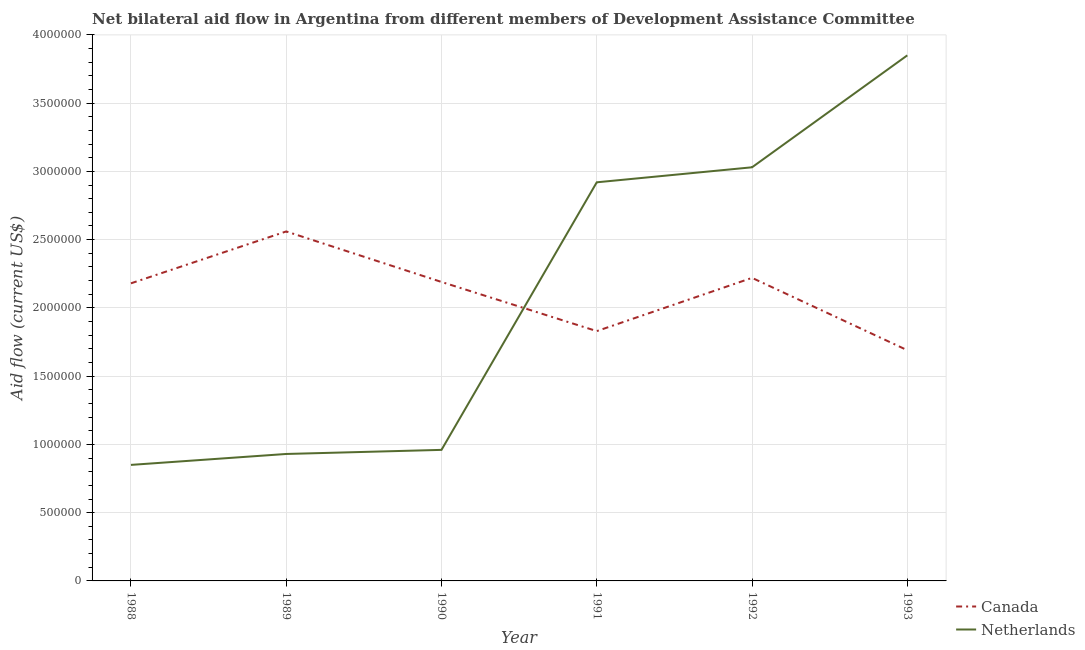Does the line corresponding to amount of aid given by canada intersect with the line corresponding to amount of aid given by netherlands?
Ensure brevity in your answer.  Yes. Is the number of lines equal to the number of legend labels?
Provide a short and direct response. Yes. What is the amount of aid given by netherlands in 1989?
Provide a short and direct response. 9.30e+05. Across all years, what is the maximum amount of aid given by canada?
Your answer should be compact. 2.56e+06. Across all years, what is the minimum amount of aid given by canada?
Your answer should be very brief. 1.69e+06. In which year was the amount of aid given by canada maximum?
Your answer should be very brief. 1989. In which year was the amount of aid given by netherlands minimum?
Provide a short and direct response. 1988. What is the total amount of aid given by canada in the graph?
Give a very brief answer. 1.27e+07. What is the difference between the amount of aid given by netherlands in 1988 and that in 1992?
Offer a terse response. -2.18e+06. What is the difference between the amount of aid given by canada in 1991 and the amount of aid given by netherlands in 1993?
Your answer should be very brief. -2.02e+06. What is the average amount of aid given by canada per year?
Your answer should be very brief. 2.11e+06. In the year 1991, what is the difference between the amount of aid given by canada and amount of aid given by netherlands?
Provide a short and direct response. -1.09e+06. In how many years, is the amount of aid given by netherlands greater than 2700000 US$?
Your answer should be very brief. 3. What is the ratio of the amount of aid given by netherlands in 1991 to that in 1993?
Your answer should be compact. 0.76. Is the difference between the amount of aid given by netherlands in 1989 and 1991 greater than the difference between the amount of aid given by canada in 1989 and 1991?
Your response must be concise. No. What is the difference between the highest and the lowest amount of aid given by netherlands?
Offer a terse response. 3.00e+06. Is the sum of the amount of aid given by netherlands in 1989 and 1992 greater than the maximum amount of aid given by canada across all years?
Your answer should be compact. Yes. How many years are there in the graph?
Your answer should be very brief. 6. What is the difference between two consecutive major ticks on the Y-axis?
Offer a very short reply. 5.00e+05. Are the values on the major ticks of Y-axis written in scientific E-notation?
Provide a succinct answer. No. Where does the legend appear in the graph?
Offer a terse response. Bottom right. How are the legend labels stacked?
Your answer should be compact. Vertical. What is the title of the graph?
Your response must be concise. Net bilateral aid flow in Argentina from different members of Development Assistance Committee. Does "Fraud firms" appear as one of the legend labels in the graph?
Keep it short and to the point. No. What is the label or title of the X-axis?
Provide a short and direct response. Year. What is the Aid flow (current US$) in Canada in 1988?
Keep it short and to the point. 2.18e+06. What is the Aid flow (current US$) in Netherlands in 1988?
Offer a terse response. 8.50e+05. What is the Aid flow (current US$) in Canada in 1989?
Keep it short and to the point. 2.56e+06. What is the Aid flow (current US$) in Netherlands in 1989?
Provide a succinct answer. 9.30e+05. What is the Aid flow (current US$) in Canada in 1990?
Ensure brevity in your answer.  2.19e+06. What is the Aid flow (current US$) in Netherlands in 1990?
Your answer should be compact. 9.60e+05. What is the Aid flow (current US$) of Canada in 1991?
Provide a succinct answer. 1.83e+06. What is the Aid flow (current US$) of Netherlands in 1991?
Give a very brief answer. 2.92e+06. What is the Aid flow (current US$) in Canada in 1992?
Your response must be concise. 2.22e+06. What is the Aid flow (current US$) of Netherlands in 1992?
Your answer should be very brief. 3.03e+06. What is the Aid flow (current US$) in Canada in 1993?
Provide a succinct answer. 1.69e+06. What is the Aid flow (current US$) in Netherlands in 1993?
Your response must be concise. 3.85e+06. Across all years, what is the maximum Aid flow (current US$) in Canada?
Ensure brevity in your answer.  2.56e+06. Across all years, what is the maximum Aid flow (current US$) in Netherlands?
Your answer should be very brief. 3.85e+06. Across all years, what is the minimum Aid flow (current US$) in Canada?
Keep it short and to the point. 1.69e+06. Across all years, what is the minimum Aid flow (current US$) in Netherlands?
Your response must be concise. 8.50e+05. What is the total Aid flow (current US$) of Canada in the graph?
Offer a very short reply. 1.27e+07. What is the total Aid flow (current US$) of Netherlands in the graph?
Provide a succinct answer. 1.25e+07. What is the difference between the Aid flow (current US$) in Canada in 1988 and that in 1989?
Give a very brief answer. -3.80e+05. What is the difference between the Aid flow (current US$) of Netherlands in 1988 and that in 1989?
Your answer should be very brief. -8.00e+04. What is the difference between the Aid flow (current US$) in Canada in 1988 and that in 1990?
Offer a very short reply. -10000. What is the difference between the Aid flow (current US$) in Netherlands in 1988 and that in 1990?
Offer a very short reply. -1.10e+05. What is the difference between the Aid flow (current US$) in Canada in 1988 and that in 1991?
Offer a terse response. 3.50e+05. What is the difference between the Aid flow (current US$) of Netherlands in 1988 and that in 1991?
Provide a short and direct response. -2.07e+06. What is the difference between the Aid flow (current US$) in Netherlands in 1988 and that in 1992?
Keep it short and to the point. -2.18e+06. What is the difference between the Aid flow (current US$) in Netherlands in 1989 and that in 1990?
Offer a very short reply. -3.00e+04. What is the difference between the Aid flow (current US$) of Canada in 1989 and that in 1991?
Offer a terse response. 7.30e+05. What is the difference between the Aid flow (current US$) of Netherlands in 1989 and that in 1991?
Provide a succinct answer. -1.99e+06. What is the difference between the Aid flow (current US$) in Canada in 1989 and that in 1992?
Keep it short and to the point. 3.40e+05. What is the difference between the Aid flow (current US$) of Netherlands in 1989 and that in 1992?
Ensure brevity in your answer.  -2.10e+06. What is the difference between the Aid flow (current US$) of Canada in 1989 and that in 1993?
Give a very brief answer. 8.70e+05. What is the difference between the Aid flow (current US$) in Netherlands in 1989 and that in 1993?
Provide a succinct answer. -2.92e+06. What is the difference between the Aid flow (current US$) in Netherlands in 1990 and that in 1991?
Give a very brief answer. -1.96e+06. What is the difference between the Aid flow (current US$) in Netherlands in 1990 and that in 1992?
Offer a very short reply. -2.07e+06. What is the difference between the Aid flow (current US$) in Netherlands in 1990 and that in 1993?
Keep it short and to the point. -2.89e+06. What is the difference between the Aid flow (current US$) in Canada in 1991 and that in 1992?
Ensure brevity in your answer.  -3.90e+05. What is the difference between the Aid flow (current US$) of Netherlands in 1991 and that in 1993?
Your answer should be very brief. -9.30e+05. What is the difference between the Aid flow (current US$) of Canada in 1992 and that in 1993?
Your answer should be very brief. 5.30e+05. What is the difference between the Aid flow (current US$) in Netherlands in 1992 and that in 1993?
Offer a terse response. -8.20e+05. What is the difference between the Aid flow (current US$) of Canada in 1988 and the Aid flow (current US$) of Netherlands in 1989?
Your response must be concise. 1.25e+06. What is the difference between the Aid flow (current US$) in Canada in 1988 and the Aid flow (current US$) in Netherlands in 1990?
Your response must be concise. 1.22e+06. What is the difference between the Aid flow (current US$) in Canada in 1988 and the Aid flow (current US$) in Netherlands in 1991?
Provide a short and direct response. -7.40e+05. What is the difference between the Aid flow (current US$) of Canada in 1988 and the Aid flow (current US$) of Netherlands in 1992?
Offer a terse response. -8.50e+05. What is the difference between the Aid flow (current US$) in Canada in 1988 and the Aid flow (current US$) in Netherlands in 1993?
Offer a very short reply. -1.67e+06. What is the difference between the Aid flow (current US$) in Canada in 1989 and the Aid flow (current US$) in Netherlands in 1990?
Ensure brevity in your answer.  1.60e+06. What is the difference between the Aid flow (current US$) of Canada in 1989 and the Aid flow (current US$) of Netherlands in 1991?
Your response must be concise. -3.60e+05. What is the difference between the Aid flow (current US$) of Canada in 1989 and the Aid flow (current US$) of Netherlands in 1992?
Offer a terse response. -4.70e+05. What is the difference between the Aid flow (current US$) in Canada in 1989 and the Aid flow (current US$) in Netherlands in 1993?
Your answer should be very brief. -1.29e+06. What is the difference between the Aid flow (current US$) in Canada in 1990 and the Aid flow (current US$) in Netherlands in 1991?
Offer a terse response. -7.30e+05. What is the difference between the Aid flow (current US$) in Canada in 1990 and the Aid flow (current US$) in Netherlands in 1992?
Keep it short and to the point. -8.40e+05. What is the difference between the Aid flow (current US$) of Canada in 1990 and the Aid flow (current US$) of Netherlands in 1993?
Your answer should be very brief. -1.66e+06. What is the difference between the Aid flow (current US$) of Canada in 1991 and the Aid flow (current US$) of Netherlands in 1992?
Your answer should be very brief. -1.20e+06. What is the difference between the Aid flow (current US$) in Canada in 1991 and the Aid flow (current US$) in Netherlands in 1993?
Offer a terse response. -2.02e+06. What is the difference between the Aid flow (current US$) of Canada in 1992 and the Aid flow (current US$) of Netherlands in 1993?
Offer a very short reply. -1.63e+06. What is the average Aid flow (current US$) in Canada per year?
Your answer should be very brief. 2.11e+06. What is the average Aid flow (current US$) in Netherlands per year?
Offer a very short reply. 2.09e+06. In the year 1988, what is the difference between the Aid flow (current US$) in Canada and Aid flow (current US$) in Netherlands?
Give a very brief answer. 1.33e+06. In the year 1989, what is the difference between the Aid flow (current US$) in Canada and Aid flow (current US$) in Netherlands?
Offer a terse response. 1.63e+06. In the year 1990, what is the difference between the Aid flow (current US$) of Canada and Aid flow (current US$) of Netherlands?
Offer a terse response. 1.23e+06. In the year 1991, what is the difference between the Aid flow (current US$) in Canada and Aid flow (current US$) in Netherlands?
Your response must be concise. -1.09e+06. In the year 1992, what is the difference between the Aid flow (current US$) of Canada and Aid flow (current US$) of Netherlands?
Provide a succinct answer. -8.10e+05. In the year 1993, what is the difference between the Aid flow (current US$) of Canada and Aid flow (current US$) of Netherlands?
Offer a very short reply. -2.16e+06. What is the ratio of the Aid flow (current US$) of Canada in 1988 to that in 1989?
Keep it short and to the point. 0.85. What is the ratio of the Aid flow (current US$) in Netherlands in 1988 to that in 1989?
Your response must be concise. 0.91. What is the ratio of the Aid flow (current US$) of Canada in 1988 to that in 1990?
Your answer should be very brief. 1. What is the ratio of the Aid flow (current US$) of Netherlands in 1988 to that in 1990?
Your answer should be compact. 0.89. What is the ratio of the Aid flow (current US$) of Canada in 1988 to that in 1991?
Make the answer very short. 1.19. What is the ratio of the Aid flow (current US$) of Netherlands in 1988 to that in 1991?
Your answer should be compact. 0.29. What is the ratio of the Aid flow (current US$) of Canada in 1988 to that in 1992?
Offer a terse response. 0.98. What is the ratio of the Aid flow (current US$) of Netherlands in 1988 to that in 1992?
Your answer should be very brief. 0.28. What is the ratio of the Aid flow (current US$) of Canada in 1988 to that in 1993?
Your response must be concise. 1.29. What is the ratio of the Aid flow (current US$) in Netherlands in 1988 to that in 1993?
Provide a succinct answer. 0.22. What is the ratio of the Aid flow (current US$) of Canada in 1989 to that in 1990?
Make the answer very short. 1.17. What is the ratio of the Aid flow (current US$) of Netherlands in 1989 to that in 1990?
Provide a short and direct response. 0.97. What is the ratio of the Aid flow (current US$) in Canada in 1989 to that in 1991?
Offer a very short reply. 1.4. What is the ratio of the Aid flow (current US$) of Netherlands in 1989 to that in 1991?
Provide a short and direct response. 0.32. What is the ratio of the Aid flow (current US$) in Canada in 1989 to that in 1992?
Make the answer very short. 1.15. What is the ratio of the Aid flow (current US$) in Netherlands in 1989 to that in 1992?
Your answer should be very brief. 0.31. What is the ratio of the Aid flow (current US$) of Canada in 1989 to that in 1993?
Offer a terse response. 1.51. What is the ratio of the Aid flow (current US$) in Netherlands in 1989 to that in 1993?
Your response must be concise. 0.24. What is the ratio of the Aid flow (current US$) of Canada in 1990 to that in 1991?
Offer a very short reply. 1.2. What is the ratio of the Aid flow (current US$) in Netherlands in 1990 to that in 1991?
Make the answer very short. 0.33. What is the ratio of the Aid flow (current US$) of Canada in 1990 to that in 1992?
Offer a terse response. 0.99. What is the ratio of the Aid flow (current US$) of Netherlands in 1990 to that in 1992?
Your answer should be compact. 0.32. What is the ratio of the Aid flow (current US$) of Canada in 1990 to that in 1993?
Provide a short and direct response. 1.3. What is the ratio of the Aid flow (current US$) in Netherlands in 1990 to that in 1993?
Keep it short and to the point. 0.25. What is the ratio of the Aid flow (current US$) of Canada in 1991 to that in 1992?
Offer a very short reply. 0.82. What is the ratio of the Aid flow (current US$) in Netherlands in 1991 to that in 1992?
Your response must be concise. 0.96. What is the ratio of the Aid flow (current US$) in Canada in 1991 to that in 1993?
Offer a very short reply. 1.08. What is the ratio of the Aid flow (current US$) in Netherlands in 1991 to that in 1993?
Offer a terse response. 0.76. What is the ratio of the Aid flow (current US$) of Canada in 1992 to that in 1993?
Provide a succinct answer. 1.31. What is the ratio of the Aid flow (current US$) in Netherlands in 1992 to that in 1993?
Ensure brevity in your answer.  0.79. What is the difference between the highest and the second highest Aid flow (current US$) in Canada?
Make the answer very short. 3.40e+05. What is the difference between the highest and the second highest Aid flow (current US$) of Netherlands?
Keep it short and to the point. 8.20e+05. What is the difference between the highest and the lowest Aid flow (current US$) of Canada?
Provide a short and direct response. 8.70e+05. 